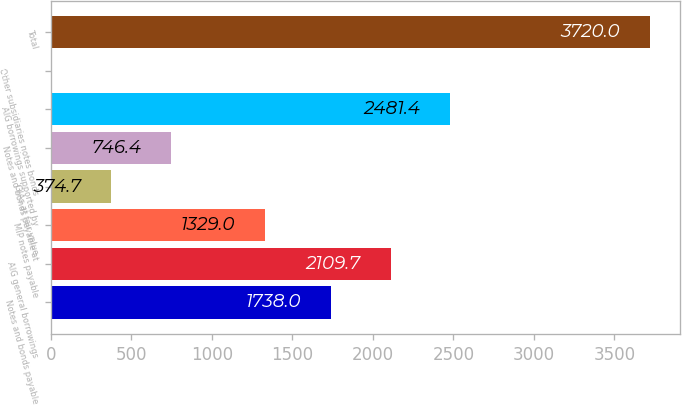Convert chart to OTSL. <chart><loc_0><loc_0><loc_500><loc_500><bar_chart><fcel>Notes and bonds payable<fcel>AIG general borrowings<fcel>MIP notes payable<fcel>GIAs at fair value<fcel>Notes and bonds payable at<fcel>AIG borrowings supported by<fcel>Other subsidiaries notes bonds<fcel>Total<nl><fcel>1738<fcel>2109.7<fcel>1329<fcel>374.7<fcel>746.4<fcel>2481.4<fcel>3<fcel>3720<nl></chart> 